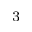Convert formula to latex. <formula><loc_0><loc_0><loc_500><loc_500>^ { 3 }</formula> 